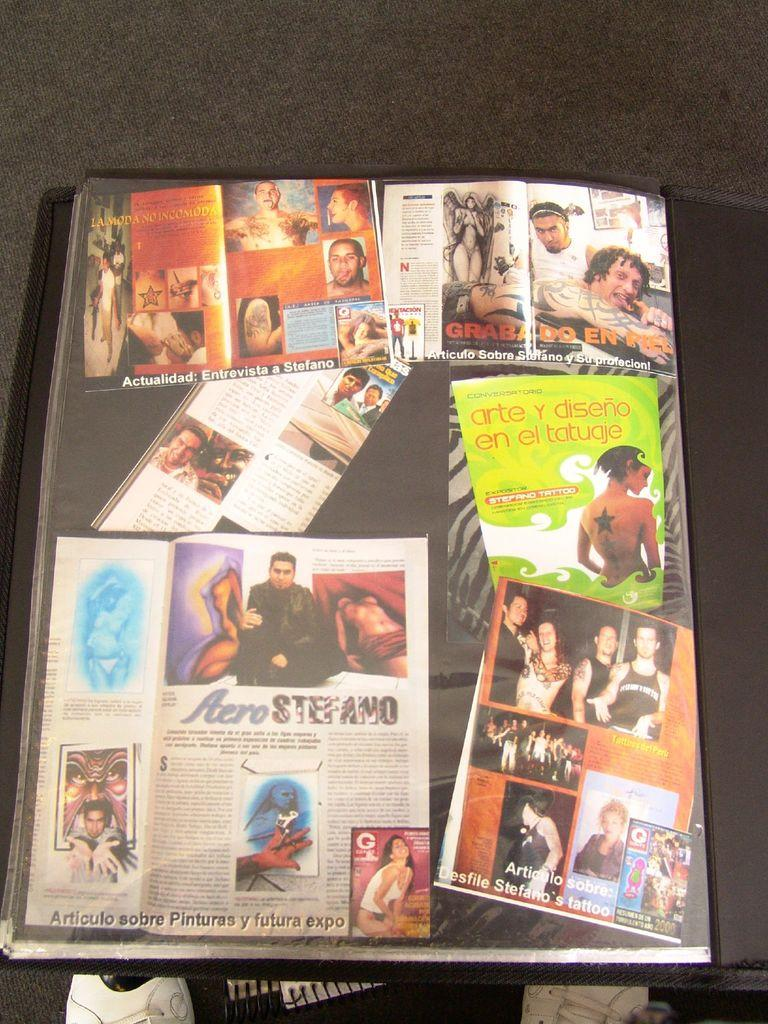<image>
Share a concise interpretation of the image provided. a book cover with foreign writing saying Articulo sobre 